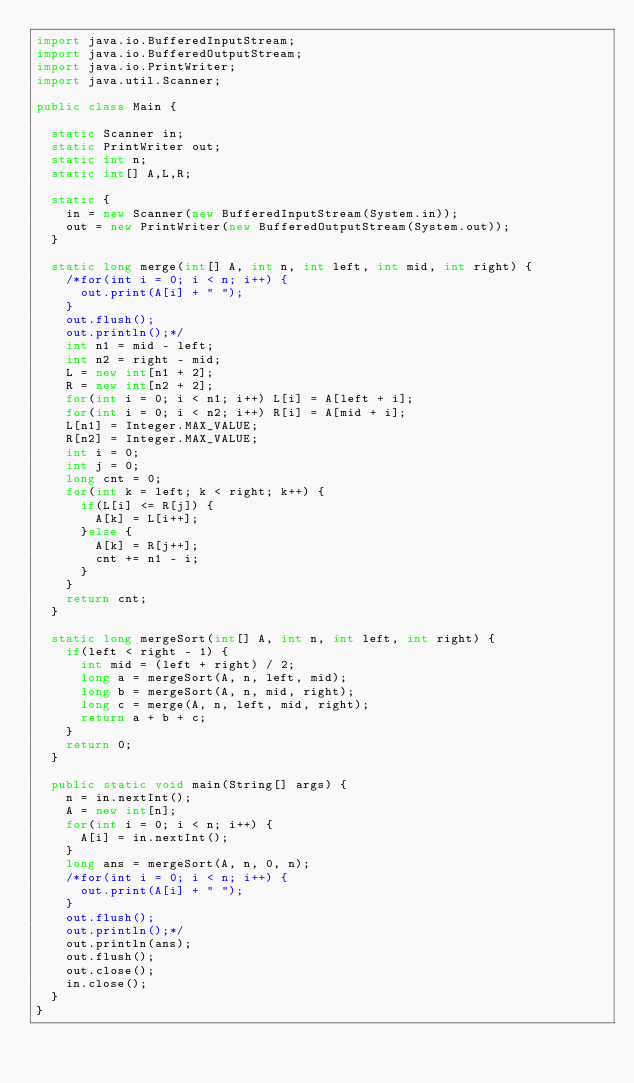<code> <loc_0><loc_0><loc_500><loc_500><_Java_>import java.io.BufferedInputStream;
import java.io.BufferedOutputStream;
import java.io.PrintWriter;
import java.util.Scanner;

public class Main {

	static Scanner in;
	static PrintWriter out;
	static int n;
	static int[] A,L,R;
	
	static {
		in = new Scanner(new BufferedInputStream(System.in));
		out = new PrintWriter(new BufferedOutputStream(System.out));
	}
	
	static long merge(int[] A, int n, int left, int mid, int right) {
		/*for(int i = 0; i < n; i++) {
			out.print(A[i] + " ");
		}
		out.flush();
		out.println();*/
		int n1 = mid - left;
		int n2 = right - mid;
		L = new int[n1 + 2];
		R = new int[n2 + 2];
		for(int i = 0; i < n1; i++) L[i] = A[left + i];
		for(int i = 0; i < n2; i++) R[i] = A[mid + i];
		L[n1] = Integer.MAX_VALUE;
		R[n2] = Integer.MAX_VALUE;
		int i = 0;
		int j = 0;
		long cnt = 0;
		for(int k = left; k < right; k++) {
			if(L[i] <= R[j]) {
				A[k] = L[i++];
			}else {
				A[k] = R[j++];
				cnt += n1 - i;
			}
		}
		return cnt;
	}
	
	static long mergeSort(int[] A, int n, int left, int right) {
		if(left < right - 1) {
			int mid = (left + right) / 2;
			long a = mergeSort(A, n, left, mid);
			long b = mergeSort(A, n, mid, right);
			long c = merge(A, n, left, mid, right);
			return a + b + c;
		}
		return 0;
	}
	
	public static void main(String[] args) {
		n = in.nextInt();
		A = new int[n];
		for(int i = 0; i < n; i++) {
			A[i] = in.nextInt();
		}
		long ans = mergeSort(A, n, 0, n);
		/*for(int i = 0; i < n; i++) {
			out.print(A[i] + " ");
		}
		out.flush();
		out.println();*/
		out.println(ans);
		out.flush();
		out.close();
		in.close();
	}
}
</code> 